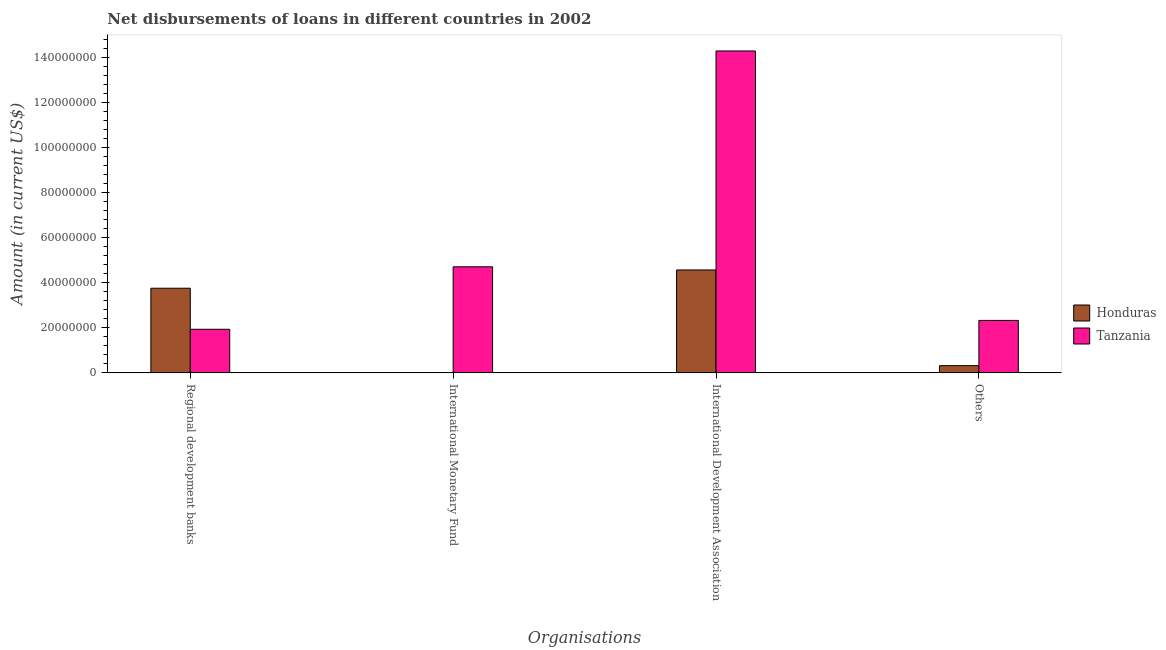How many bars are there on the 4th tick from the right?
Your answer should be compact. 2. What is the label of the 3rd group of bars from the left?
Provide a short and direct response. International Development Association. What is the amount of loan disimbursed by other organisations in Honduras?
Your answer should be compact. 3.20e+06. Across all countries, what is the maximum amount of loan disimbursed by international development association?
Give a very brief answer. 1.43e+08. In which country was the amount of loan disimbursed by international development association maximum?
Your answer should be very brief. Tanzania. What is the total amount of loan disimbursed by international development association in the graph?
Offer a terse response. 1.88e+08. What is the difference between the amount of loan disimbursed by international development association in Honduras and that in Tanzania?
Keep it short and to the point. -9.71e+07. What is the difference between the amount of loan disimbursed by regional development banks in Tanzania and the amount of loan disimbursed by other organisations in Honduras?
Make the answer very short. 1.61e+07. What is the average amount of loan disimbursed by other organisations per country?
Offer a terse response. 1.32e+07. What is the difference between the amount of loan disimbursed by regional development banks and amount of loan disimbursed by international monetary fund in Tanzania?
Make the answer very short. -2.77e+07. In how many countries, is the amount of loan disimbursed by international development association greater than 68000000 US$?
Provide a short and direct response. 1. What is the ratio of the amount of loan disimbursed by other organisations in Honduras to that in Tanzania?
Provide a succinct answer. 0.14. Is the amount of loan disimbursed by other organisations in Honduras less than that in Tanzania?
Ensure brevity in your answer.  Yes. Is the difference between the amount of loan disimbursed by regional development banks in Tanzania and Honduras greater than the difference between the amount of loan disimbursed by other organisations in Tanzania and Honduras?
Give a very brief answer. No. What is the difference between the highest and the second highest amount of loan disimbursed by regional development banks?
Your response must be concise. 1.82e+07. What is the difference between the highest and the lowest amount of loan disimbursed by international monetary fund?
Offer a terse response. 4.70e+07. In how many countries, is the amount of loan disimbursed by international monetary fund greater than the average amount of loan disimbursed by international monetary fund taken over all countries?
Ensure brevity in your answer.  1. Is it the case that in every country, the sum of the amount of loan disimbursed by other organisations and amount of loan disimbursed by international monetary fund is greater than the sum of amount of loan disimbursed by international development association and amount of loan disimbursed by regional development banks?
Make the answer very short. No. Is it the case that in every country, the sum of the amount of loan disimbursed by regional development banks and amount of loan disimbursed by international monetary fund is greater than the amount of loan disimbursed by international development association?
Provide a short and direct response. No. How many bars are there?
Your answer should be compact. 7. Does the graph contain any zero values?
Your response must be concise. Yes. What is the title of the graph?
Your answer should be compact. Net disbursements of loans in different countries in 2002. What is the label or title of the X-axis?
Offer a terse response. Organisations. What is the label or title of the Y-axis?
Your response must be concise. Amount (in current US$). What is the Amount (in current US$) of Honduras in Regional development banks?
Offer a very short reply. 3.75e+07. What is the Amount (in current US$) of Tanzania in Regional development banks?
Offer a terse response. 1.93e+07. What is the Amount (in current US$) of Tanzania in International Monetary Fund?
Provide a short and direct response. 4.70e+07. What is the Amount (in current US$) of Honduras in International Development Association?
Offer a terse response. 4.56e+07. What is the Amount (in current US$) in Tanzania in International Development Association?
Ensure brevity in your answer.  1.43e+08. What is the Amount (in current US$) of Honduras in Others?
Offer a terse response. 3.20e+06. What is the Amount (in current US$) of Tanzania in Others?
Provide a short and direct response. 2.33e+07. Across all Organisations, what is the maximum Amount (in current US$) of Honduras?
Provide a short and direct response. 4.56e+07. Across all Organisations, what is the maximum Amount (in current US$) in Tanzania?
Your answer should be very brief. 1.43e+08. Across all Organisations, what is the minimum Amount (in current US$) in Honduras?
Provide a short and direct response. 0. Across all Organisations, what is the minimum Amount (in current US$) of Tanzania?
Give a very brief answer. 1.93e+07. What is the total Amount (in current US$) of Honduras in the graph?
Your answer should be very brief. 8.64e+07. What is the total Amount (in current US$) of Tanzania in the graph?
Offer a very short reply. 2.32e+08. What is the difference between the Amount (in current US$) in Tanzania in Regional development banks and that in International Monetary Fund?
Make the answer very short. -2.77e+07. What is the difference between the Amount (in current US$) of Honduras in Regional development banks and that in International Development Association?
Keep it short and to the point. -8.10e+06. What is the difference between the Amount (in current US$) in Tanzania in Regional development banks and that in International Development Association?
Give a very brief answer. -1.23e+08. What is the difference between the Amount (in current US$) in Honduras in Regional development banks and that in Others?
Your response must be concise. 3.43e+07. What is the difference between the Amount (in current US$) in Tanzania in Regional development banks and that in Others?
Your answer should be compact. -3.94e+06. What is the difference between the Amount (in current US$) of Tanzania in International Monetary Fund and that in International Development Association?
Your answer should be very brief. -9.57e+07. What is the difference between the Amount (in current US$) in Tanzania in International Monetary Fund and that in Others?
Give a very brief answer. 2.38e+07. What is the difference between the Amount (in current US$) in Honduras in International Development Association and that in Others?
Offer a terse response. 4.25e+07. What is the difference between the Amount (in current US$) in Tanzania in International Development Association and that in Others?
Your response must be concise. 1.20e+08. What is the difference between the Amount (in current US$) in Honduras in Regional development banks and the Amount (in current US$) in Tanzania in International Monetary Fund?
Offer a terse response. -9.50e+06. What is the difference between the Amount (in current US$) in Honduras in Regional development banks and the Amount (in current US$) in Tanzania in International Development Association?
Your response must be concise. -1.05e+08. What is the difference between the Amount (in current US$) of Honduras in Regional development banks and the Amount (in current US$) of Tanzania in Others?
Provide a short and direct response. 1.43e+07. What is the difference between the Amount (in current US$) of Honduras in International Development Association and the Amount (in current US$) of Tanzania in Others?
Your answer should be compact. 2.24e+07. What is the average Amount (in current US$) of Honduras per Organisations?
Offer a very short reply. 2.16e+07. What is the average Amount (in current US$) in Tanzania per Organisations?
Ensure brevity in your answer.  5.81e+07. What is the difference between the Amount (in current US$) of Honduras and Amount (in current US$) of Tanzania in Regional development banks?
Keep it short and to the point. 1.82e+07. What is the difference between the Amount (in current US$) of Honduras and Amount (in current US$) of Tanzania in International Development Association?
Give a very brief answer. -9.71e+07. What is the difference between the Amount (in current US$) in Honduras and Amount (in current US$) in Tanzania in Others?
Make the answer very short. -2.01e+07. What is the ratio of the Amount (in current US$) in Tanzania in Regional development banks to that in International Monetary Fund?
Your answer should be very brief. 0.41. What is the ratio of the Amount (in current US$) of Honduras in Regional development banks to that in International Development Association?
Your response must be concise. 0.82. What is the ratio of the Amount (in current US$) of Tanzania in Regional development banks to that in International Development Association?
Make the answer very short. 0.14. What is the ratio of the Amount (in current US$) of Honduras in Regional development banks to that in Others?
Offer a terse response. 11.74. What is the ratio of the Amount (in current US$) in Tanzania in Regional development banks to that in Others?
Your answer should be compact. 0.83. What is the ratio of the Amount (in current US$) in Tanzania in International Monetary Fund to that in International Development Association?
Keep it short and to the point. 0.33. What is the ratio of the Amount (in current US$) in Tanzania in International Monetary Fund to that in Others?
Your answer should be compact. 2.02. What is the ratio of the Amount (in current US$) of Honduras in International Development Association to that in Others?
Provide a succinct answer. 14.28. What is the ratio of the Amount (in current US$) in Tanzania in International Development Association to that in Others?
Ensure brevity in your answer.  6.14. What is the difference between the highest and the second highest Amount (in current US$) of Honduras?
Keep it short and to the point. 8.10e+06. What is the difference between the highest and the second highest Amount (in current US$) of Tanzania?
Your answer should be compact. 9.57e+07. What is the difference between the highest and the lowest Amount (in current US$) of Honduras?
Ensure brevity in your answer.  4.56e+07. What is the difference between the highest and the lowest Amount (in current US$) of Tanzania?
Provide a succinct answer. 1.23e+08. 